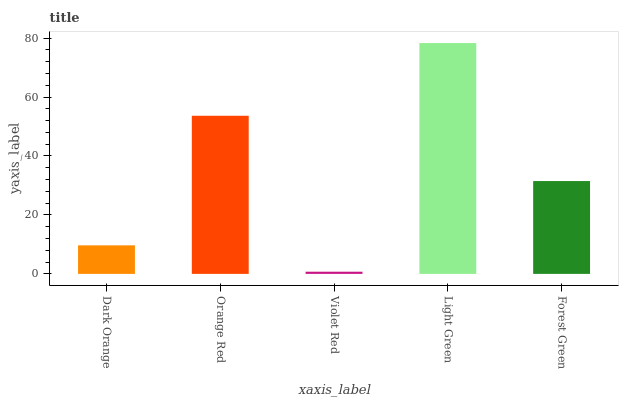Is Orange Red the minimum?
Answer yes or no. No. Is Orange Red the maximum?
Answer yes or no. No. Is Orange Red greater than Dark Orange?
Answer yes or no. Yes. Is Dark Orange less than Orange Red?
Answer yes or no. Yes. Is Dark Orange greater than Orange Red?
Answer yes or no. No. Is Orange Red less than Dark Orange?
Answer yes or no. No. Is Forest Green the high median?
Answer yes or no. Yes. Is Forest Green the low median?
Answer yes or no. Yes. Is Dark Orange the high median?
Answer yes or no. No. Is Dark Orange the low median?
Answer yes or no. No. 